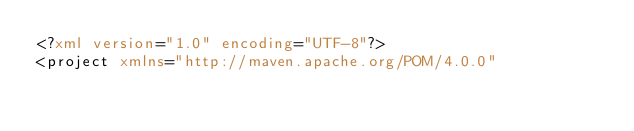<code> <loc_0><loc_0><loc_500><loc_500><_XML_><?xml version="1.0" encoding="UTF-8"?>
<project xmlns="http://maven.apache.org/POM/4.0.0"</code> 